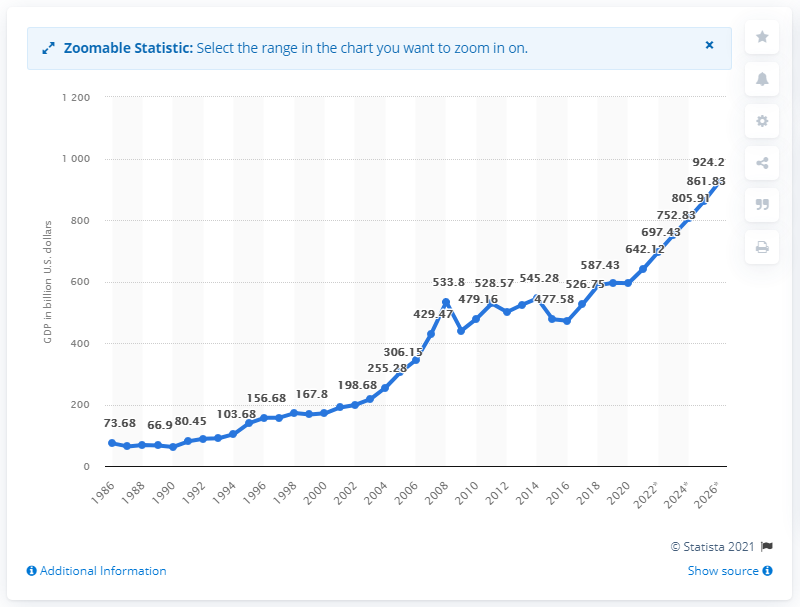Highlight a few significant elements in this photo. In 2019, the Gross Domestic Product (GDP) of Poland reached an all-time high of 594.18 billion US dollars. It is projected that by 2025, the Gross Domestic Product (GDP) of Poland will reach a value of 861.83. 